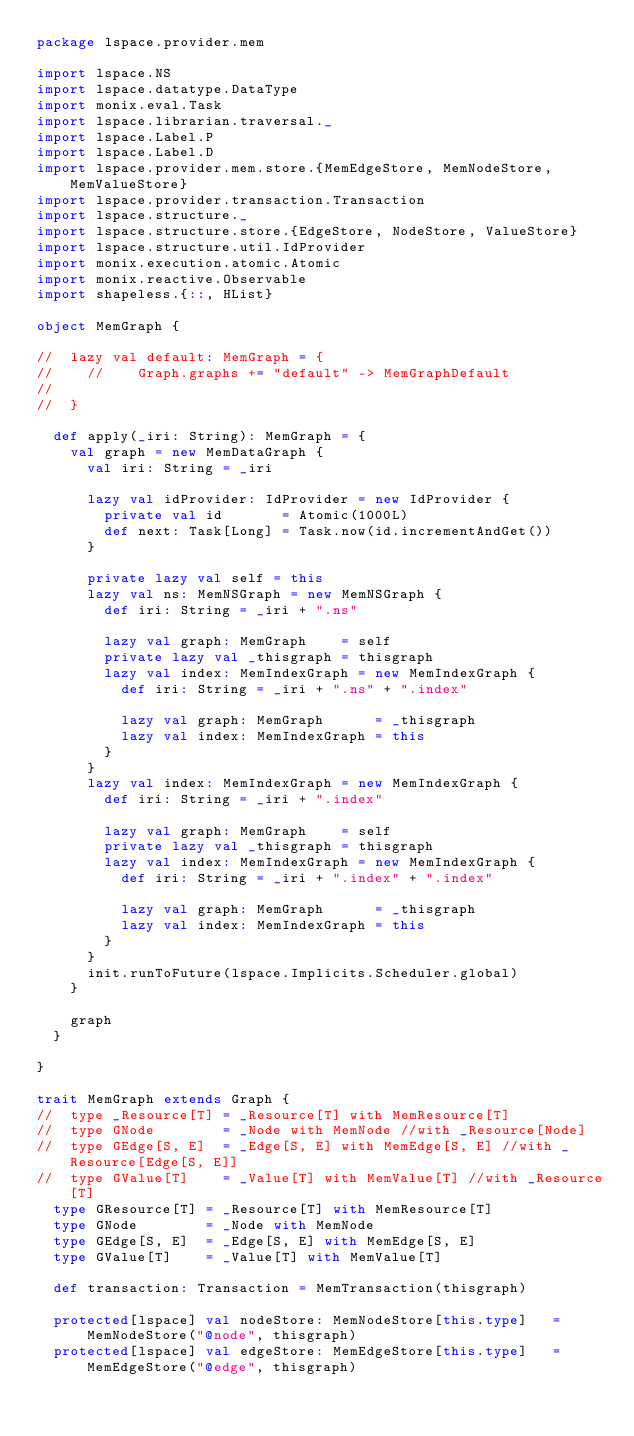<code> <loc_0><loc_0><loc_500><loc_500><_Scala_>package lspace.provider.mem

import lspace.NS
import lspace.datatype.DataType
import monix.eval.Task
import lspace.librarian.traversal._
import lspace.Label.P
import lspace.Label.D
import lspace.provider.mem.store.{MemEdgeStore, MemNodeStore, MemValueStore}
import lspace.provider.transaction.Transaction
import lspace.structure._
import lspace.structure.store.{EdgeStore, NodeStore, ValueStore}
import lspace.structure.util.IdProvider
import monix.execution.atomic.Atomic
import monix.reactive.Observable
import shapeless.{::, HList}

object MemGraph {

//  lazy val default: MemGraph = {
//    //    Graph.graphs += "default" -> MemGraphDefault
//
//  }

  def apply(_iri: String): MemGraph = {
    val graph = new MemDataGraph {
      val iri: String = _iri

      lazy val idProvider: IdProvider = new IdProvider {
        private val id       = Atomic(1000L)
        def next: Task[Long] = Task.now(id.incrementAndGet())
      }

      private lazy val self = this
      lazy val ns: MemNSGraph = new MemNSGraph {
        def iri: String = _iri + ".ns"

        lazy val graph: MemGraph    = self
        private lazy val _thisgraph = thisgraph
        lazy val index: MemIndexGraph = new MemIndexGraph {
          def iri: String = _iri + ".ns" + ".index"

          lazy val graph: MemGraph      = _thisgraph
          lazy val index: MemIndexGraph = this
        }
      }
      lazy val index: MemIndexGraph = new MemIndexGraph {
        def iri: String = _iri + ".index"

        lazy val graph: MemGraph    = self
        private lazy val _thisgraph = thisgraph
        lazy val index: MemIndexGraph = new MemIndexGraph {
          def iri: String = _iri + ".index" + ".index"

          lazy val graph: MemGraph      = _thisgraph
          lazy val index: MemIndexGraph = this
        }
      }
      init.runToFuture(lspace.Implicits.Scheduler.global)
    }

    graph
  }

}

trait MemGraph extends Graph {
//  type _Resource[T] = _Resource[T] with MemResource[T]
//  type GNode        = _Node with MemNode //with _Resource[Node]
//  type GEdge[S, E]  = _Edge[S, E] with MemEdge[S, E] //with _Resource[Edge[S, E]]
//  type GValue[T]    = _Value[T] with MemValue[T] //with _Resource[T]
  type GResource[T] = _Resource[T] with MemResource[T]
  type GNode        = _Node with MemNode
  type GEdge[S, E]  = _Edge[S, E] with MemEdge[S, E]
  type GValue[T]    = _Value[T] with MemValue[T]

  def transaction: Transaction = MemTransaction(thisgraph)

  protected[lspace] val nodeStore: MemNodeStore[this.type]   = MemNodeStore("@node", thisgraph)
  protected[lspace] val edgeStore: MemEdgeStore[this.type]   = MemEdgeStore("@edge", thisgraph)</code> 